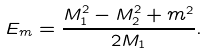Convert formula to latex. <formula><loc_0><loc_0><loc_500><loc_500>E _ { m } = \frac { M _ { 1 } ^ { 2 } - M _ { 2 } ^ { 2 } + m ^ { 2 } } { 2 M _ { 1 } } .</formula> 